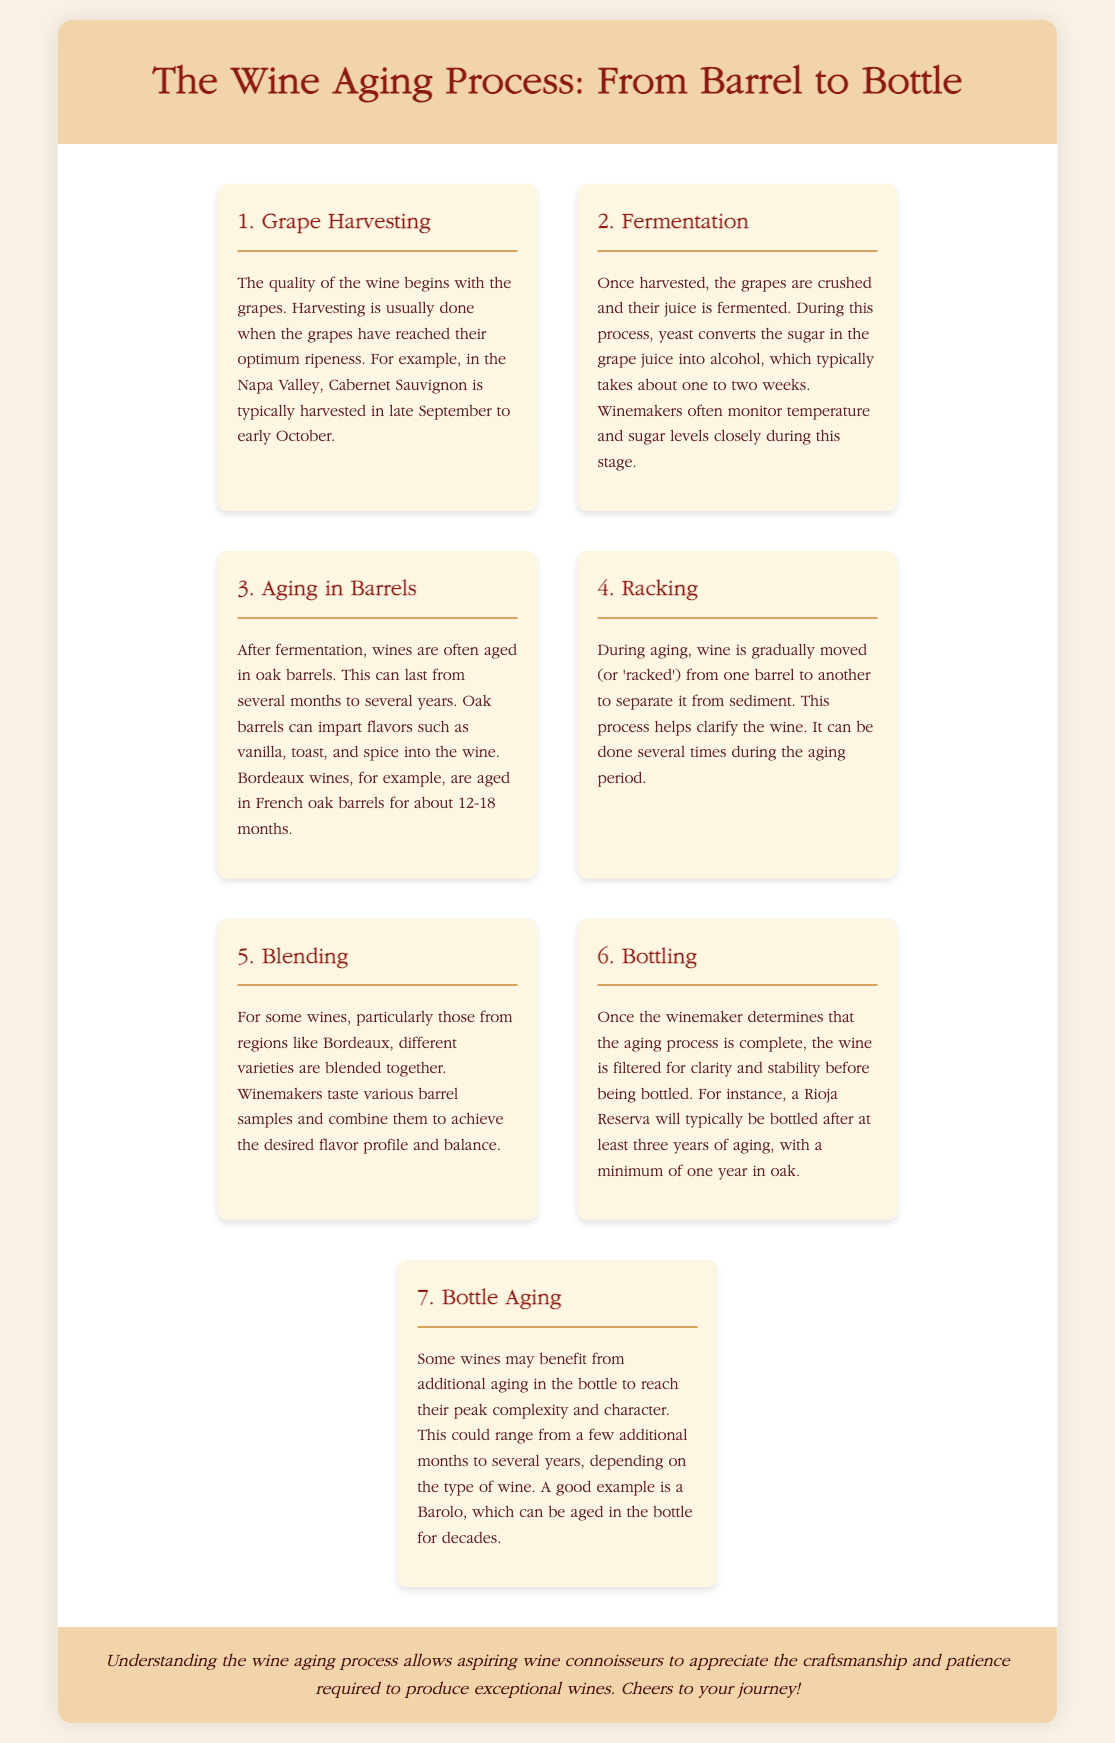What is the first step in the wine aging process? The first step in the process is Grape Harvesting.
Answer: Grape Harvesting How long does fermentation typically take? Fermentation typically takes about one to two weeks.
Answer: one to two weeks What is the aging duration for Bordeaux wines in oak barrels? Bordeaux wines are aged in French oak barrels for about 12-18 months.
Answer: 12-18 months What is the purpose of racking in the aging process? Racking helps clarify the wine by separating it from sediment.
Answer: clarify the wine How long is a Rioja Reserva typically aged before bottling? A Rioja Reserva is typically bottled after at least three years of aging.
Answer: three years How many types of wines are blended together in the blending step? Different varieties are blended together during the blending step.
Answer: different varieties What benefits does bottle aging provide? Bottle aging allows wines to reach their peak complexity and character.
Answer: peak complexity and character Which wine can be aged in the bottle for decades? A Barolo can be aged in the bottle for decades.
Answer: Barolo 